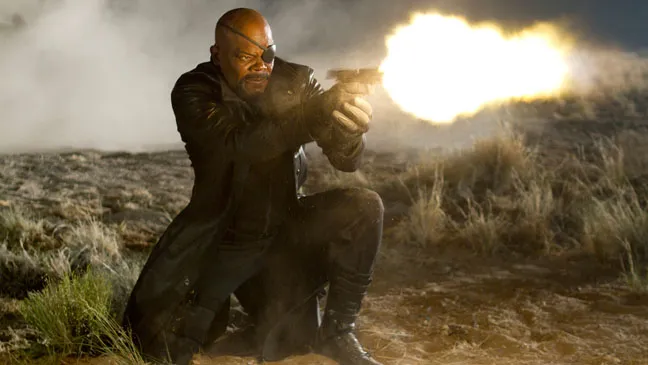What do you think is going on in this snapshot? In the image, we see a character who closely resembles Nick Fury from the Marvel Cinematic Universe, played by sharegpt4v/samuel L. Jackson. He is captured in a dramatic pose, crouching on the rocky terrain of a desert. The setting is bathed in dust and smoke, suggesting that a recent or ongoing skirmish has taken place. Displaying his distinctive, determined demeanor, Nick Fury dons his trademark long black coat and an eye patch. He is gripping a gun in both hands, which is firing a bright, blazing orange flame, adding to the intensity of the scene. His focused expression and the turmoil surrounding him emphasize the high-stakes nature of this moment. 